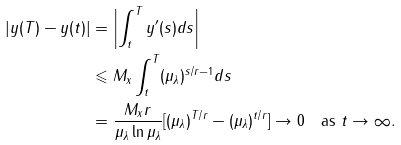<formula> <loc_0><loc_0><loc_500><loc_500>| y ( T ) - y ( t ) | & = \left | \int _ { t } ^ { T } y ^ { \prime } ( s ) d s \right | \\ & \leqslant M _ { x } \int _ { t } ^ { T } ( \mu _ { \lambda } ) ^ { s / r - 1 } d s \\ & = \frac { M _ { x } r } { \mu _ { \lambda } \ln \mu _ { \lambda } } [ ( \mu _ { \lambda } ) ^ { T / r } - ( \mu _ { \lambda } ) ^ { t / r } ] \to 0 \quad \text {as } t \to \infty .</formula> 